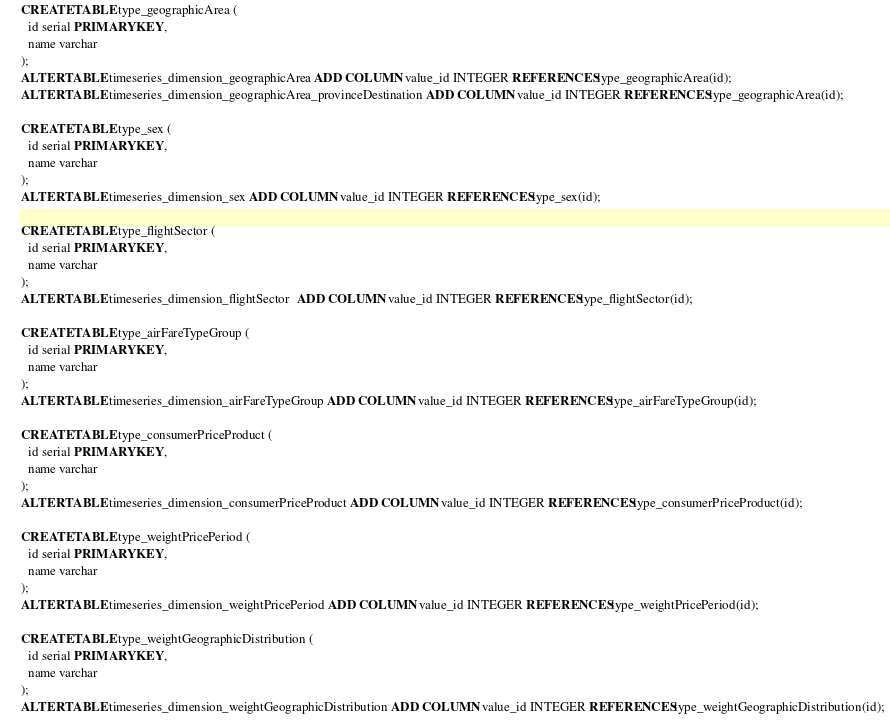<code> <loc_0><loc_0><loc_500><loc_500><_SQL_>CREATE TABLE type_geographicArea (
  id serial PRIMARY KEY,
  name varchar
);
ALTER TABLE timeseries_dimension_geographicArea ADD COLUMN value_id INTEGER REFERENCES type_geographicArea(id);
ALTER TABLE timeseries_dimension_geographicArea_provinceDestination ADD COLUMN value_id INTEGER REFERENCES type_geographicArea(id);

CREATE TABLE type_sex (
  id serial PRIMARY KEY,
  name varchar
);
ALTER TABLE timeseries_dimension_sex ADD COLUMN value_id INTEGER REFERENCES type_sex(id);

CREATE TABLE type_flightSector (
  id serial PRIMARY KEY,
  name varchar
);
ALTER TABLE timeseries_dimension_flightSector  ADD COLUMN value_id INTEGER REFERENCES type_flightSector(id);

CREATE TABLE type_airFareTypeGroup (
  id serial PRIMARY KEY,
  name varchar
);
ALTER TABLE timeseries_dimension_airFareTypeGroup ADD COLUMN value_id INTEGER REFERENCES type_airFareTypeGroup(id);

CREATE TABLE type_consumerPriceProduct (
  id serial PRIMARY KEY,
  name varchar
);
ALTER TABLE timeseries_dimension_consumerPriceProduct ADD COLUMN value_id INTEGER REFERENCES type_consumerPriceProduct(id);

CREATE TABLE type_weightPricePeriod (
  id serial PRIMARY KEY,
  name varchar
);
ALTER TABLE timeseries_dimension_weightPricePeriod ADD COLUMN value_id INTEGER REFERENCES type_weightPricePeriod(id);

CREATE TABLE type_weightGeographicDistribution (
  id serial PRIMARY KEY,
  name varchar
);
ALTER TABLE timeseries_dimension_weightGeographicDistribution ADD COLUMN value_id INTEGER REFERENCES type_weightGeographicDistribution(id);
</code> 